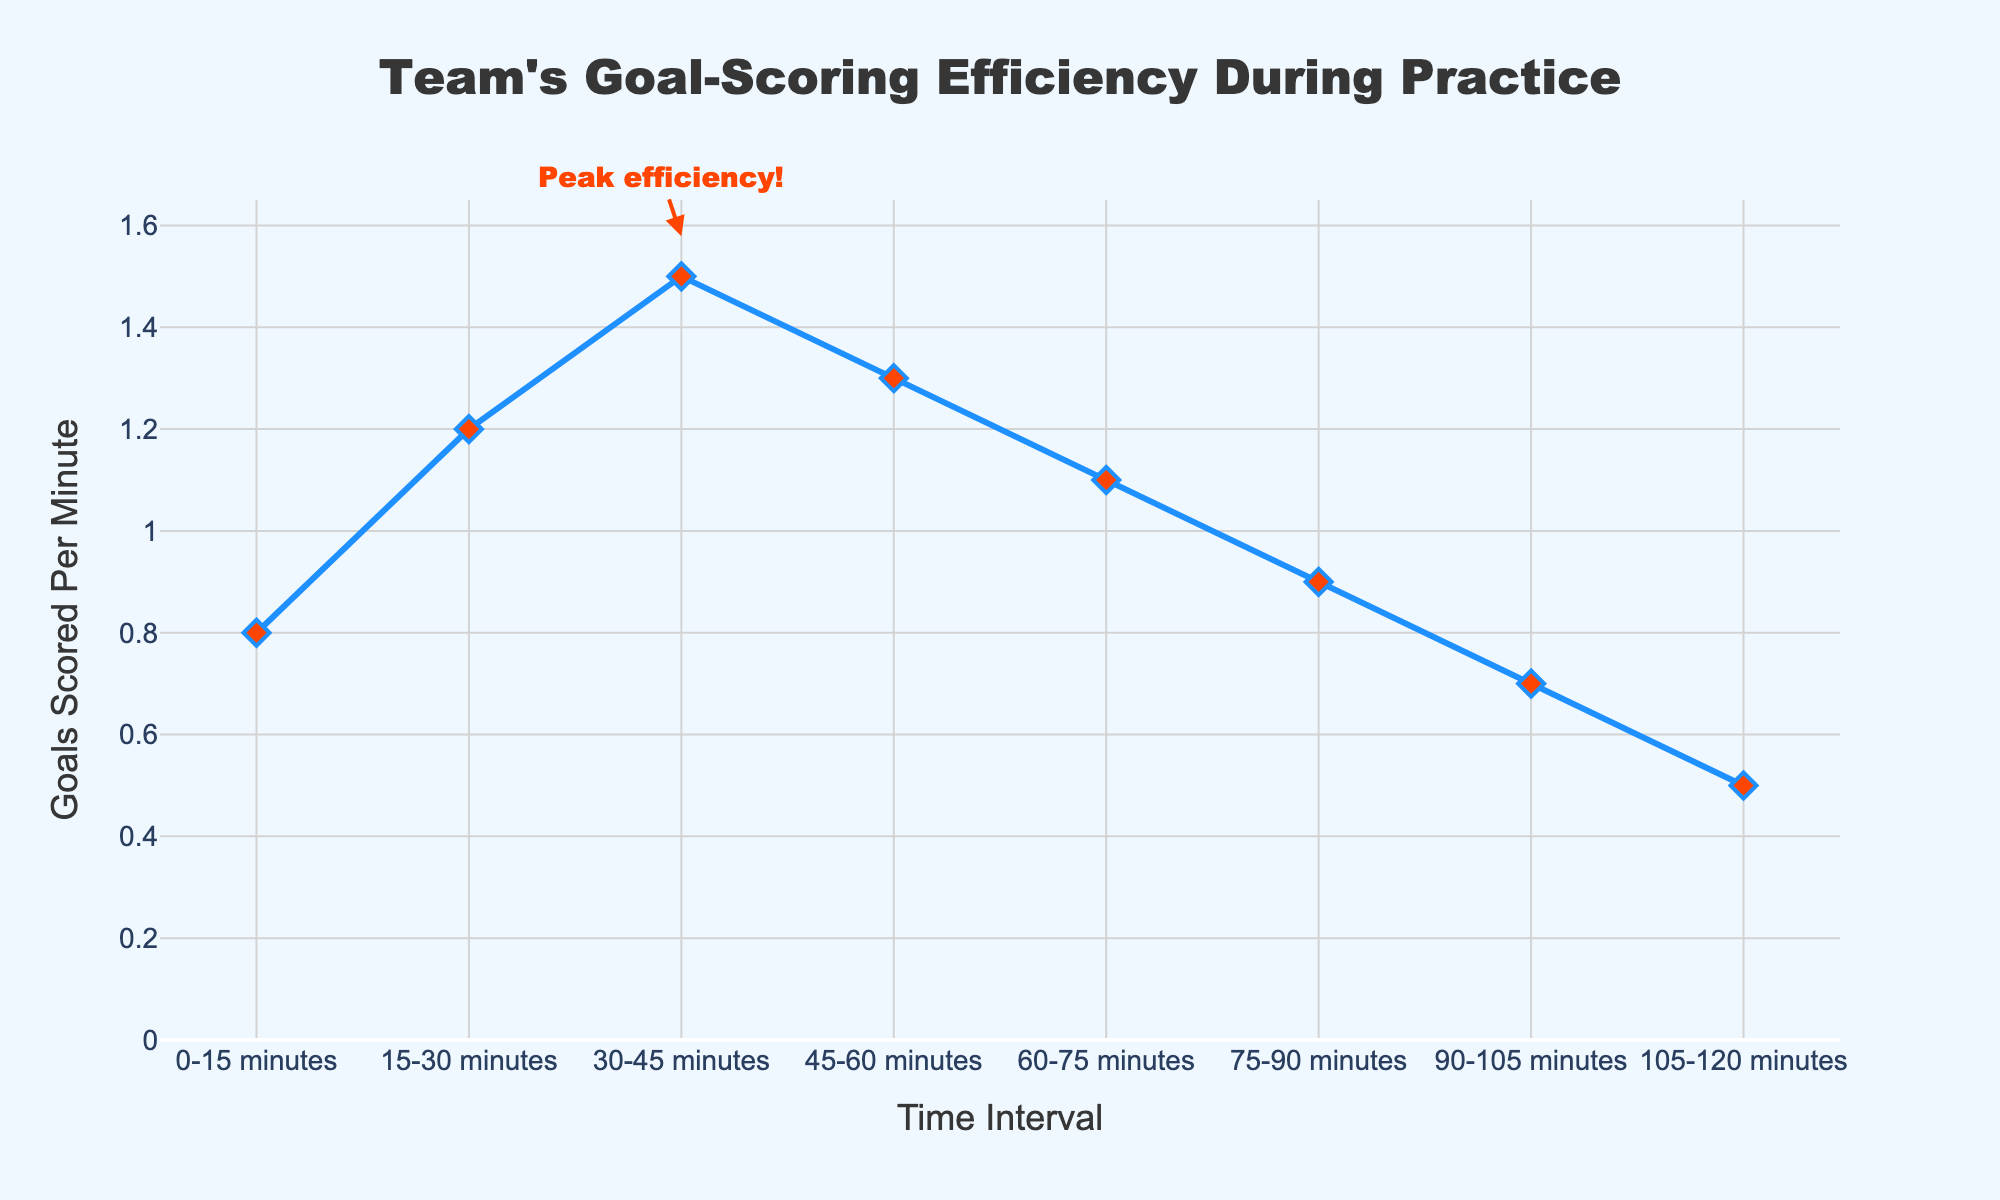What time interval shows the highest goal-scoring efficiency? The annotation and height of the line mark show that during the 30-45 minutes interval, the team has the highest goal-scoring efficiency at 1.5 goals per minute.
Answer: 30-45 minutes How much higher is the goal-scoring efficiency at 30-45 minutes compared to 105-120 minutes? At 30-45 minutes, the efficiency is 1.5 goals per minute, while at 105-120 minutes, it is 0.5 goals per minute. The difference is 1.5 - 0.5 = 1.0 goals per minute.
Answer: 1.0 goals per minute Between which two intervals is there the biggest drop in goal-scoring efficiency? By observing the slopes of the line, the biggest drop occurs between 60-75 minutes and 90-105 minutes, going from 1.1 to 0.7 goals per minute, a decrease of 0.4 goals per minute.
Answer: 60-75 minutes and 90-105 minutes What is the average goal-scoring efficiency across all intervals? Sum the goal-scoring values (0.8 + 1.2 + 1.5 + 1.3 + 1.1 + 0.9 + 0.7 + 0.5 = 8.0) and divide by the number of intervals (8). The average is 8.0 / 8 = 1.0 goals per minute.
Answer: 1.0 goals per minute During which interval does the goal-scoring efficiency start to decline after peaking? The efficiency peaks at 30-45 minutes (1.5 goals per minute) and starts to decline in the next interval, 45-60 minutes (1.3 goals per minute).
Answer: 45-60 minutes How do the goal-scoring efficiencies compare between the first 15 minutes and the last 15 minutes? The efficiency is 0.8 goals per minute in the first 0-15 minutes interval and 0.5 goals per minute in the last 105-120 minutes interval. The first 15 minutes has 0.3 goals per minute higher efficiency.
Answer: 0.3 higher for the first 15 minutes What is the total number of goals scored during the 30-45 minutes interval assuming a continuous rate? The efficiency during 30-45 minutes is 1.5 goals per minute. Multiplying by the number of minutes (15), the total goals in this interval are 1.5 * 15 = 22.5 goals.
Answer: 22.5 goals What is the rate of change in goal-scoring efficiency from 45-60 minutes to 90-105 minutes? The efficiency declines from 1.3 at 45-60 minutes to 0.7 at 90-105 minutes. The rate of change over 45 minutes is (0.7 - 1.3) / 45 = -0.6 / 45 ≈ -0.0133 goals per minute per minute.
Answer: -0.0133 goals per minute per minute 